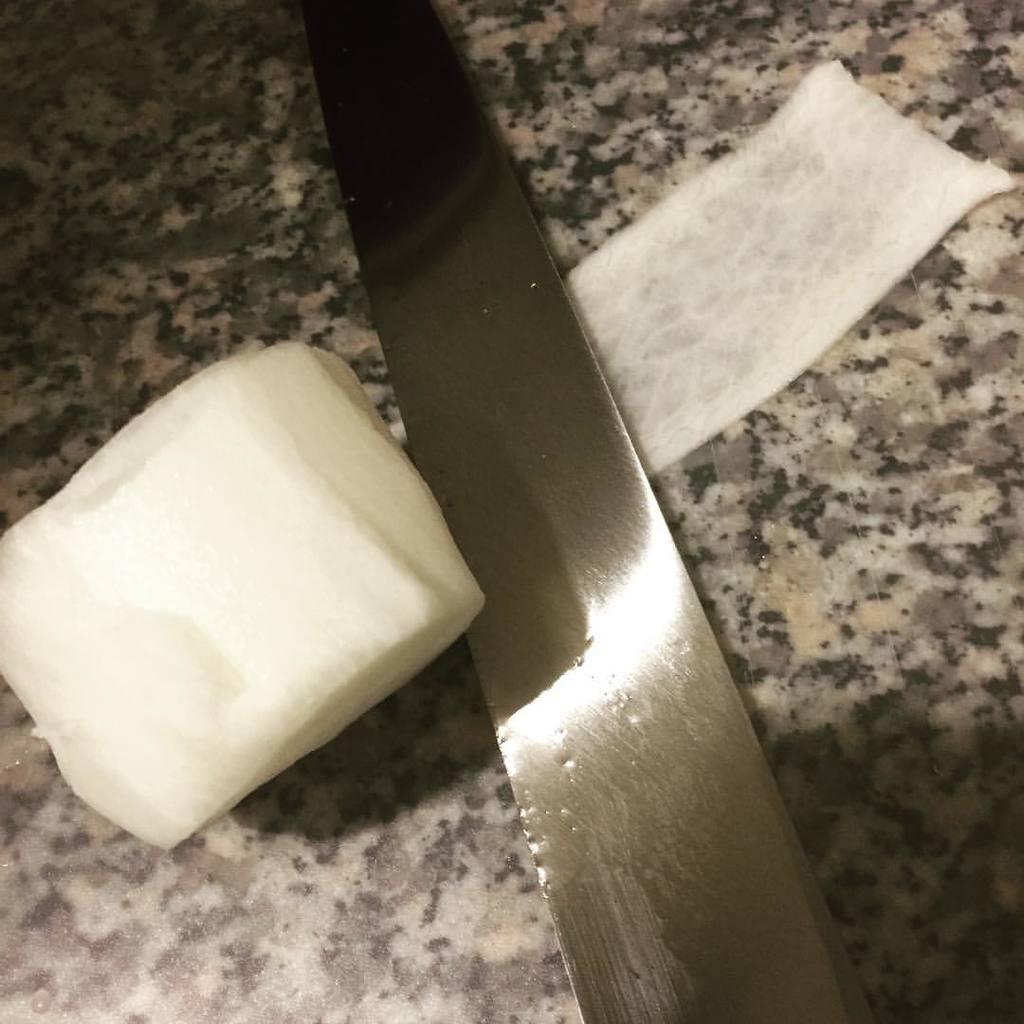What piece of furniture is visible in the image? There is a table in the image. What utensil can be seen on the table? There is a knife on the table. What else is present on the table besides the knife? There is an object on the table. What type of class is being taught in the image? There is no class or teaching activity depicted in the image. 